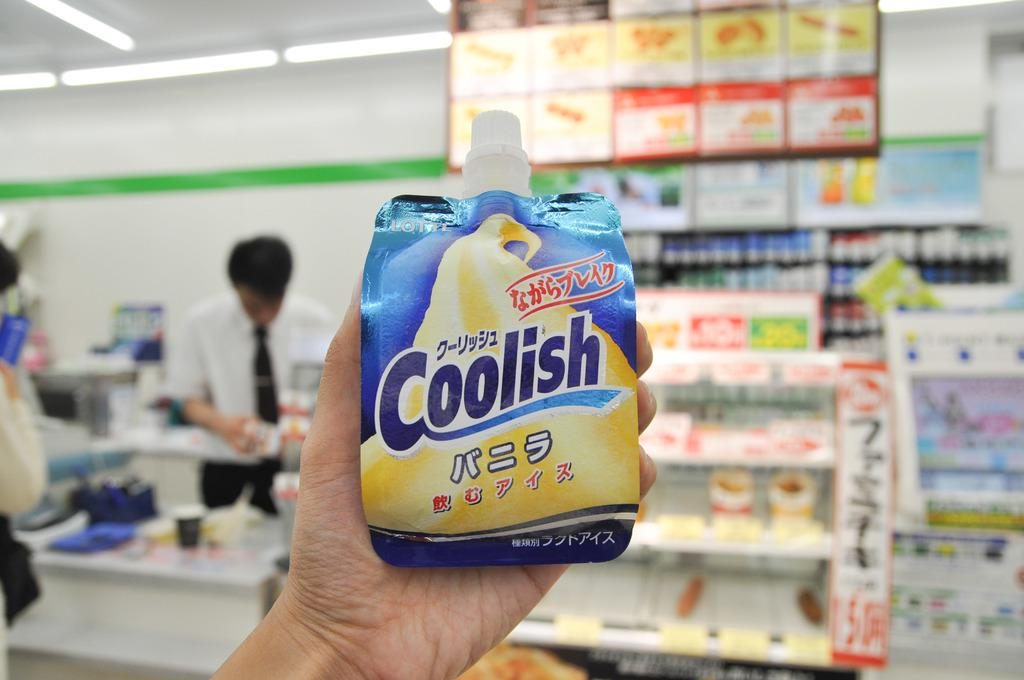<image>
Summarize the visual content of the image. an item that has the word coolish on it 